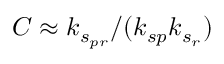<formula> <loc_0><loc_0><loc_500><loc_500>C \approx k _ { s _ { p r } } / ( k _ { s p } k _ { s _ { r } } )</formula> 